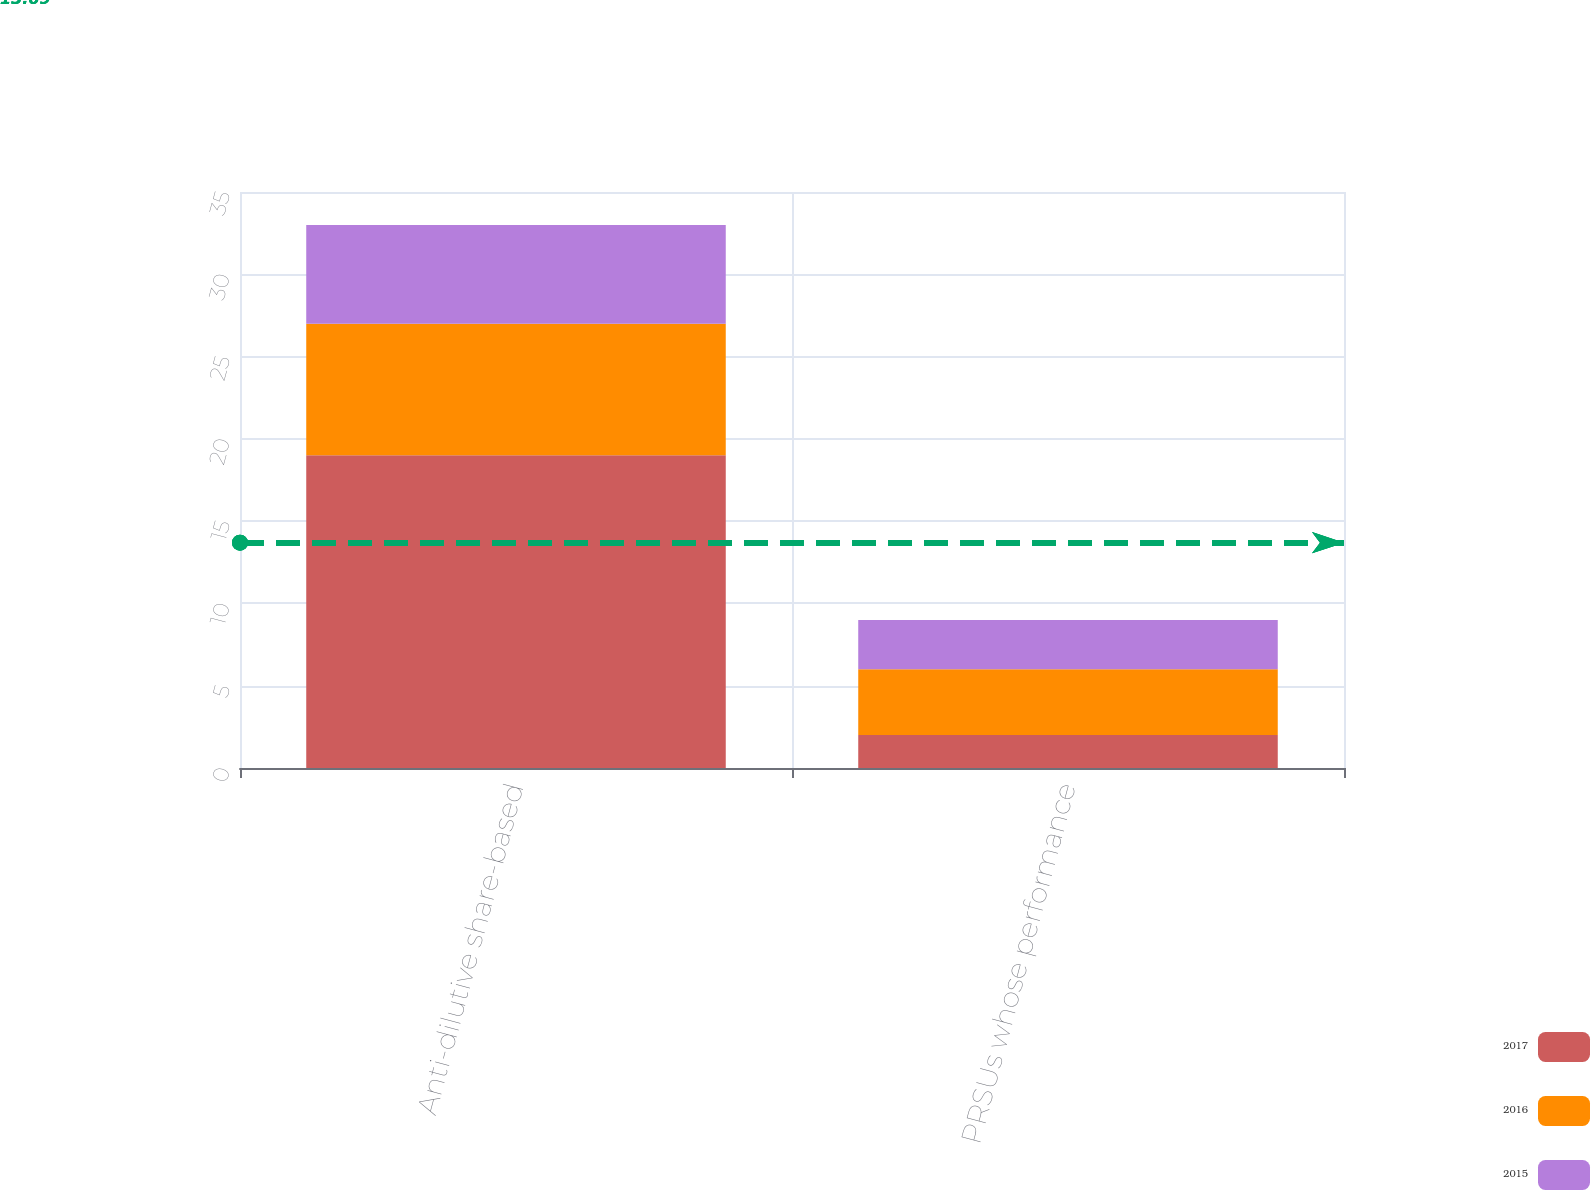Convert chart to OTSL. <chart><loc_0><loc_0><loc_500><loc_500><stacked_bar_chart><ecel><fcel>Anti-dilutive share-based<fcel>PRSUs whose performance<nl><fcel>2017<fcel>19<fcel>2<nl><fcel>2016<fcel>8<fcel>4<nl><fcel>2015<fcel>6<fcel>3<nl></chart> 